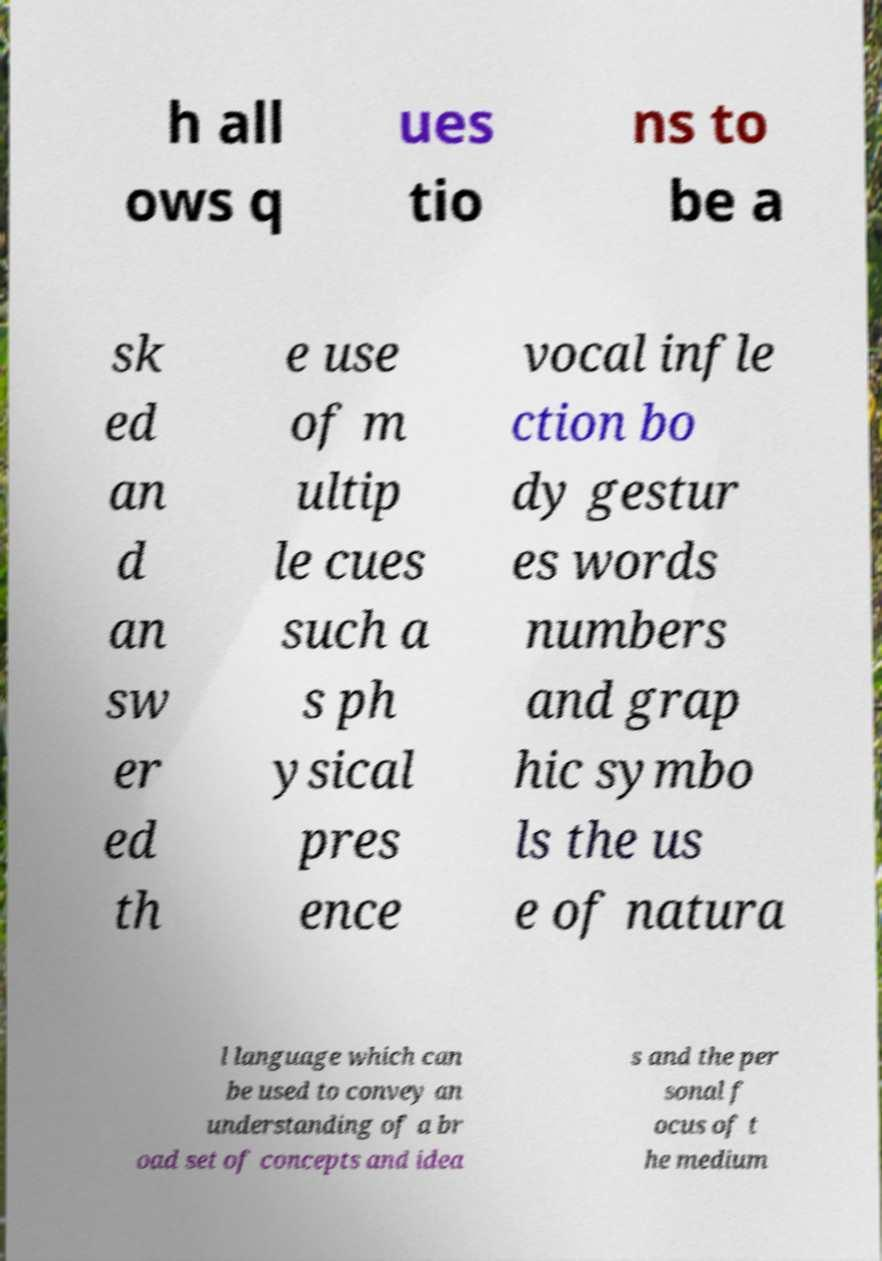I need the written content from this picture converted into text. Can you do that? h all ows q ues tio ns to be a sk ed an d an sw er ed th e use of m ultip le cues such a s ph ysical pres ence vocal infle ction bo dy gestur es words numbers and grap hic symbo ls the us e of natura l language which can be used to convey an understanding of a br oad set of concepts and idea s and the per sonal f ocus of t he medium 